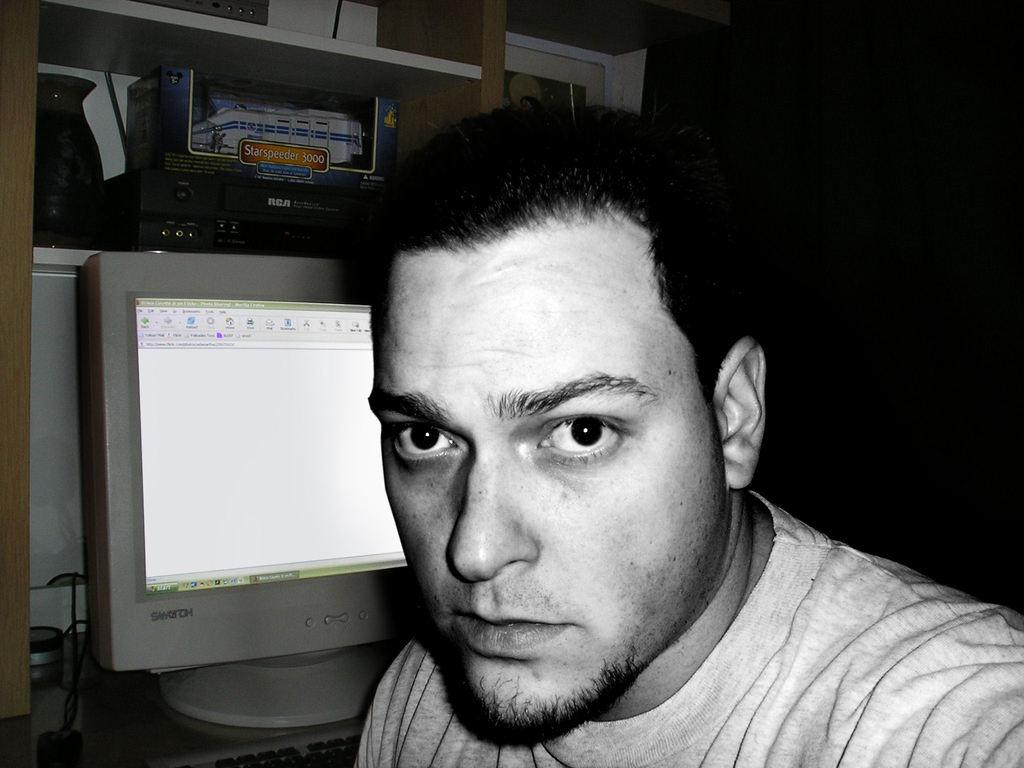What is the color scheme of the image? The image is black and white. Who is present in the image? There is a man in the image. What objects can be seen in the background of the image? There is a monitor, a keyboard, a rack with a vase, and an unspecified object in the background of the image. Can you see the deer breathing in the image? There is no deer present in the image, so it is not possible to see it breathing. 